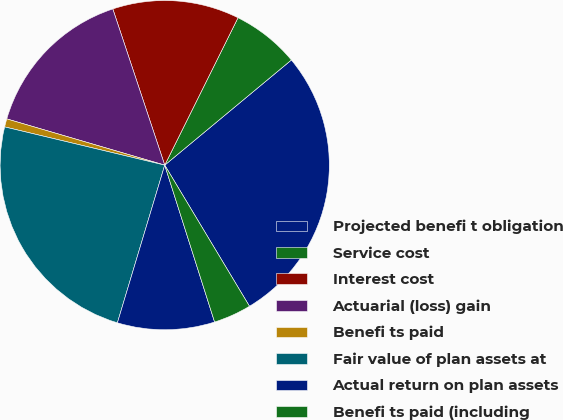Convert chart to OTSL. <chart><loc_0><loc_0><loc_500><loc_500><pie_chart><fcel>Projected benefi t obligation<fcel>Service cost<fcel>Interest cost<fcel>Actuarial (loss) gain<fcel>Benefi ts paid<fcel>Fair value of plan assets at<fcel>Actual return on plan assets<fcel>Benefi ts paid (including<nl><fcel>27.42%<fcel>6.63%<fcel>12.45%<fcel>15.36%<fcel>0.8%<fcel>24.09%<fcel>9.54%<fcel>3.71%<nl></chart> 